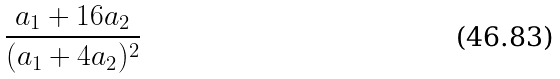Convert formula to latex. <formula><loc_0><loc_0><loc_500><loc_500>\frac { a _ { 1 } + 1 6 a _ { 2 } } { ( a _ { 1 } + 4 a _ { 2 } ) ^ { 2 } }</formula> 